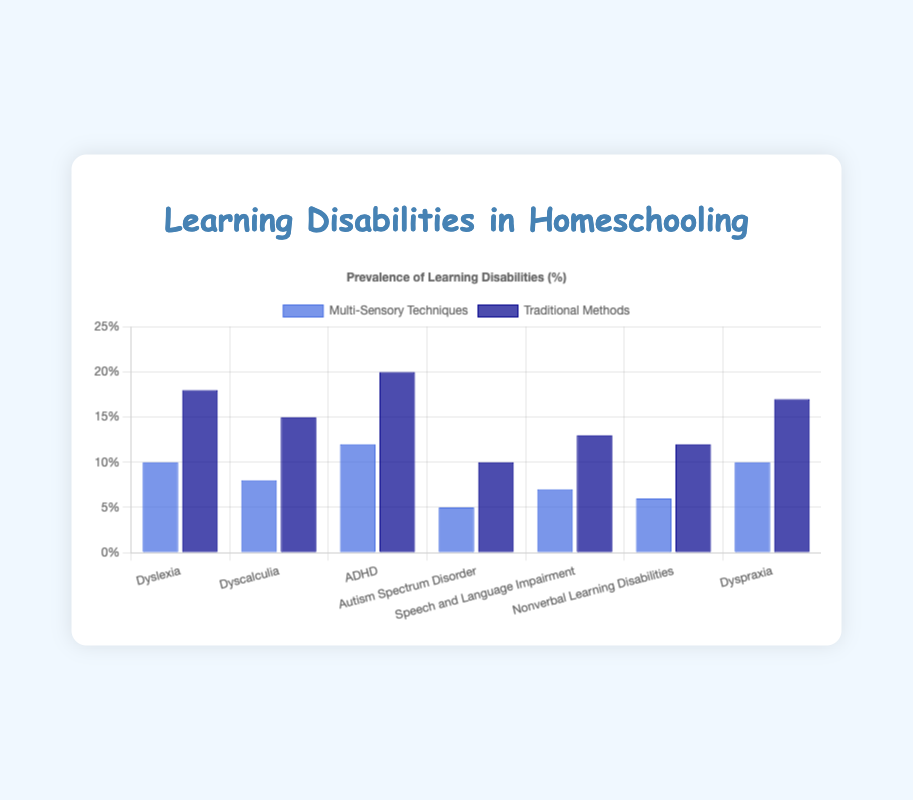What's the difference in the prevalence of Dyslexia between Multi-Sensory Techniques and Traditional Methods? To find the difference, subtract the prevalence of Multi-Sensory Techniques (10%) from the prevalence of Traditional Methods (18%).
Answer: 8% How does the prevalence of ADHD compare to Dyslexia using Multi-Sensory Techniques? Looking at the heights of the blue bars, ADHD has a prevalence of 12%, and Dyslexia has a prevalence of 10%.
Answer: ADHD is higher Which learning disability shows the greatest difference in prevalence between Multi-Sensory Techniques and Traditional Methods? Compare the difference for each learning disability: Dyslexia (8%), Dyscalculia (7%), ADHD (8%), Autism Spectrum Disorder (5%), Speech and Language Impairment (6%), Nonverbal Learning Disabilities (6%), Dyspraxia (7%). The greatest differences are found with Dyslexia and ADHD, each at 8%.
Answer: Dyslexia and ADHD For which learning disability is the prevalence exactly twice as high using Traditional Methods compared to Multi-Sensory Techniques? Doubling the prevalence percentages for Multi-Sensory Techniques: Dyslexia (20%), Dyscalculia (16%), ADHD (24%), Autism Spectrum Disorder (10%), Speech and Language Impairment (14%), Nonverbal Learning Disabilities (12%), Dyspraxia (20%). Only Autism Spectrum Disorder has a doubled value that exactly matches the Traditional Methods prevalence of 10%.
Answer: Autism Spectrum Disorder What is the combined prevalence for Dyscalculia and Dyspraxia using Multi-Sensory Techniques? Add the prevalence percentages for Dyscalculia (8%) and Dyspraxia (10%) using Multi-Sensory Techniques: 8% + 10% = 18%.
Answer: 18% Which color bar is highest for each learning disability? By visually inspecting the bars’ heights for all learning disabilities: Traditional Methods (dark blue) are higher for all categories.
Answer: Dark Blue What is the average prevalence of all listed learning disabilities using Multi-Sensory Techniques? Sum all prevalence percentages for Multi-Sensory Techniques (10% + 8% + 12% + 5% + 7% + 6% + 10% = 58%) and divide by the number of disabilities (7): 58% / 7 ≈ 8.29%.
Answer: 8.29% By how much is the prevalence of Speech and Language Impairment reduced when using Multi-Sensory Techniques compared to Traditional Methods? Subtract the prevalence of Multi-Sensory Techniques (7%) from Traditional Methods (13%): 13% - 7% = 6%.
Answer: 6% Are there any learning disabilities where the prevalence is equal for both methods? Compare the prevalence percentages for Multi-Sensory Techniques and Traditional Methods side by side; there are no equal values.
Answer: No What is the most common learning disability using Traditional Methods? Identify the highest percentage from the dark blue bars: ADHD at 20%.
Answer: ADHD 